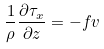<formula> <loc_0><loc_0><loc_500><loc_500>\frac { 1 } { \rho } \frac { \partial \tau _ { x } } { \partial z } = - f v</formula> 